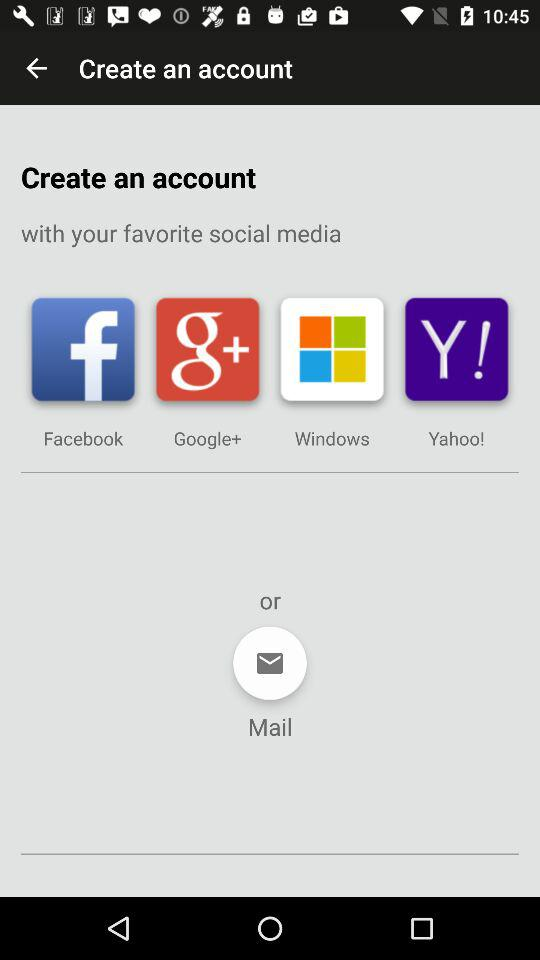What are the options through which we can create an account? The options through which you can create an account are "Facebook", "Google+", "Windows", "Yahoo!" and "Mail". 